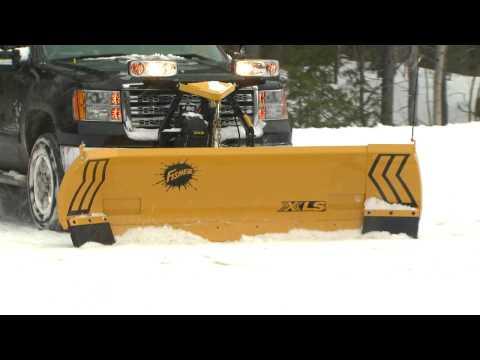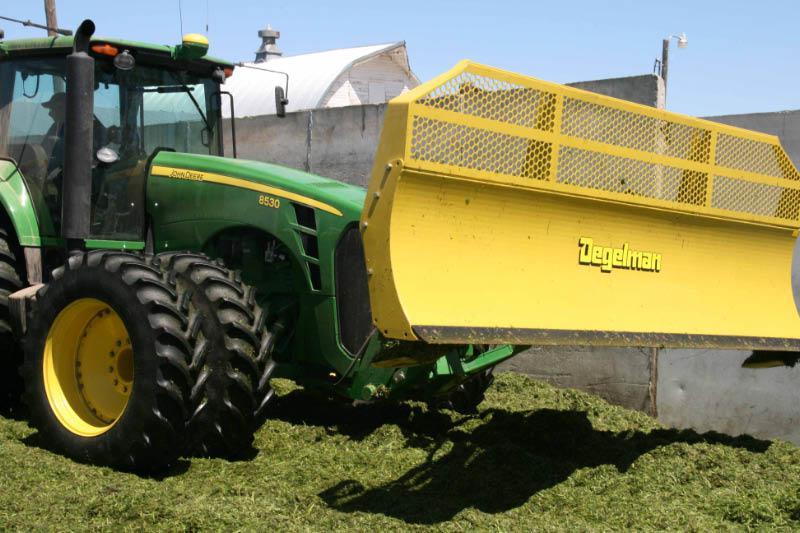The first image is the image on the left, the second image is the image on the right. Evaluate the accuracy of this statement regarding the images: "A person is standing near a yellow heavy duty truck.". Is it true? Answer yes or no. No. The first image is the image on the left, the second image is the image on the right. Evaluate the accuracy of this statement regarding the images: "In one image, on a snowy street, a yellow snow blade is attached to a dark truck with extra headlights.". Is it true? Answer yes or no. Yes. 